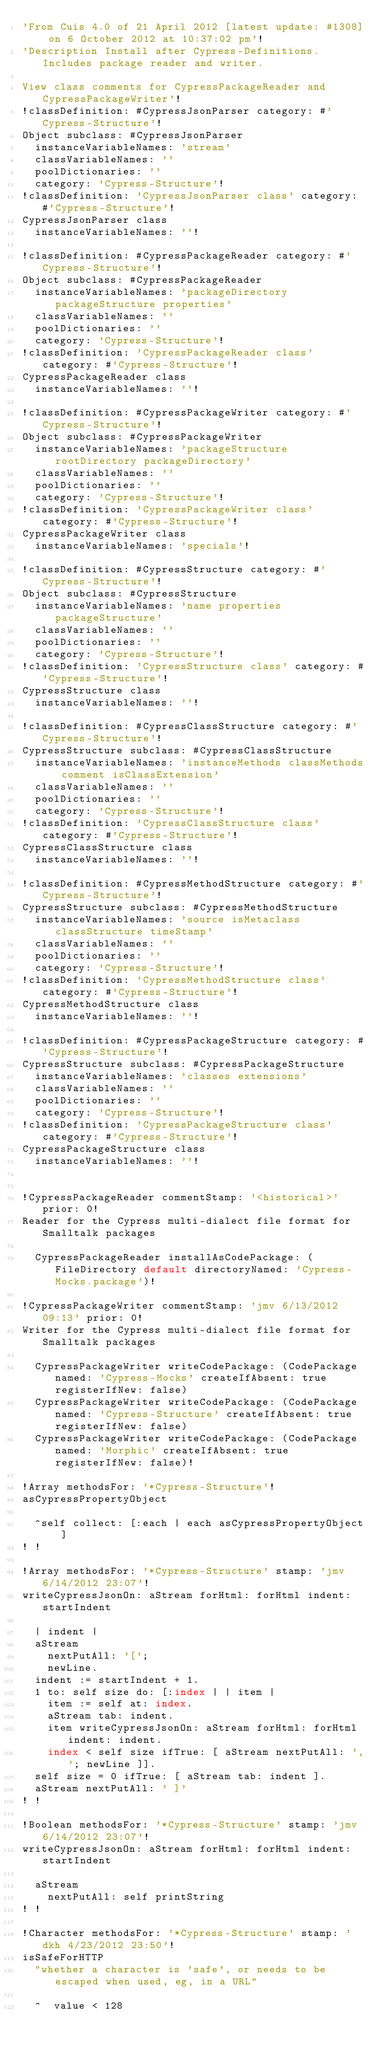Convert code to text. <code><loc_0><loc_0><loc_500><loc_500><_SQL_>'From Cuis 4.0 of 21 April 2012 [latest update: #1308] on 6 October 2012 at 10:37:02 pm'!
'Description Install after Cypress-Definitions. Includes package reader and writer.

View class comments for CypressPackageReader and CypressPackageWriter'!
!classDefinition: #CypressJsonParser category: #'Cypress-Structure'!
Object subclass: #CypressJsonParser
	instanceVariableNames: 'stream'
	classVariableNames: ''
	poolDictionaries: ''
	category: 'Cypress-Structure'!
!classDefinition: 'CypressJsonParser class' category: #'Cypress-Structure'!
CypressJsonParser class
	instanceVariableNames: ''!

!classDefinition: #CypressPackageReader category: #'Cypress-Structure'!
Object subclass: #CypressPackageReader
	instanceVariableNames: 'packageDirectory packageStructure properties'
	classVariableNames: ''
	poolDictionaries: ''
	category: 'Cypress-Structure'!
!classDefinition: 'CypressPackageReader class' category: #'Cypress-Structure'!
CypressPackageReader class
	instanceVariableNames: ''!

!classDefinition: #CypressPackageWriter category: #'Cypress-Structure'!
Object subclass: #CypressPackageWriter
	instanceVariableNames: 'packageStructure rootDirectory packageDirectory'
	classVariableNames: ''
	poolDictionaries: ''
	category: 'Cypress-Structure'!
!classDefinition: 'CypressPackageWriter class' category: #'Cypress-Structure'!
CypressPackageWriter class
	instanceVariableNames: 'specials'!

!classDefinition: #CypressStructure category: #'Cypress-Structure'!
Object subclass: #CypressStructure
	instanceVariableNames: 'name properties packageStructure'
	classVariableNames: ''
	poolDictionaries: ''
	category: 'Cypress-Structure'!
!classDefinition: 'CypressStructure class' category: #'Cypress-Structure'!
CypressStructure class
	instanceVariableNames: ''!

!classDefinition: #CypressClassStructure category: #'Cypress-Structure'!
CypressStructure subclass: #CypressClassStructure
	instanceVariableNames: 'instanceMethods classMethods comment isClassExtension'
	classVariableNames: ''
	poolDictionaries: ''
	category: 'Cypress-Structure'!
!classDefinition: 'CypressClassStructure class' category: #'Cypress-Structure'!
CypressClassStructure class
	instanceVariableNames: ''!

!classDefinition: #CypressMethodStructure category: #'Cypress-Structure'!
CypressStructure subclass: #CypressMethodStructure
	instanceVariableNames: 'source isMetaclass classStructure timeStamp'
	classVariableNames: ''
	poolDictionaries: ''
	category: 'Cypress-Structure'!
!classDefinition: 'CypressMethodStructure class' category: #'Cypress-Structure'!
CypressMethodStructure class
	instanceVariableNames: ''!

!classDefinition: #CypressPackageStructure category: #'Cypress-Structure'!
CypressStructure subclass: #CypressPackageStructure
	instanceVariableNames: 'classes extensions'
	classVariableNames: ''
	poolDictionaries: ''
	category: 'Cypress-Structure'!
!classDefinition: 'CypressPackageStructure class' category: #'Cypress-Structure'!
CypressPackageStructure class
	instanceVariableNames: ''!


!CypressPackageReader commentStamp: '<historical>' prior: 0!
Reader for the Cypress multi-dialect file format for Smalltalk packages

	CypressPackageReader installAsCodePackage: (FileDirectory default directoryNamed: 'Cypress-Mocks.package')!

!CypressPackageWriter commentStamp: 'jmv 6/13/2012 09:13' prior: 0!
Writer for the Cypress multi-dialect file format for Smalltalk packages

	CypressPackageWriter writeCodePackage: (CodePackage named: 'Cypress-Mocks' createIfAbsent: true registerIfNew: false)
	CypressPackageWriter writeCodePackage: (CodePackage named: 'Cypress-Structure' createIfAbsent: true registerIfNew: false)
	CypressPackageWriter writeCodePackage: (CodePackage named: 'Morphic' createIfAbsent: true registerIfNew: false)!

!Array methodsFor: '*Cypress-Structure'!
asCypressPropertyObject

	^self collect: [:each | each asCypressPropertyObject ]
! !

!Array methodsFor: '*Cypress-Structure' stamp: 'jmv 6/14/2012 23:07'!
writeCypressJsonOn: aStream forHtml: forHtml indent: startIndent

	| indent |
	aStream 
		nextPutAll: '[';
		newLine.
	indent := startIndent + 1.
	1 to: self size do: [:index | | item | 
		item := self at: index.
		aStream tab: indent.
		item writeCypressJsonOn: aStream forHtml: forHtml indent: indent.
		index < self size ifTrue: [ aStream nextPutAll: ','; newLine ]].
	self size = 0 ifTrue: [ aStream tab: indent ].
	aStream nextPutAll: ' ]'
! !

!Boolean methodsFor: '*Cypress-Structure' stamp: 'jmv 6/14/2012 23:07'!
writeCypressJsonOn: aStream forHtml: forHtml indent: startIndent

	aStream 
		nextPutAll: self printString
! !

!Character methodsFor: '*Cypress-Structure' stamp: 'dkh 4/23/2012 23:50'!
isSafeForHTTP
	"whether a character is 'safe', or needs to be escaped when used, eg, in a URL"

	^  value < 128</code> 